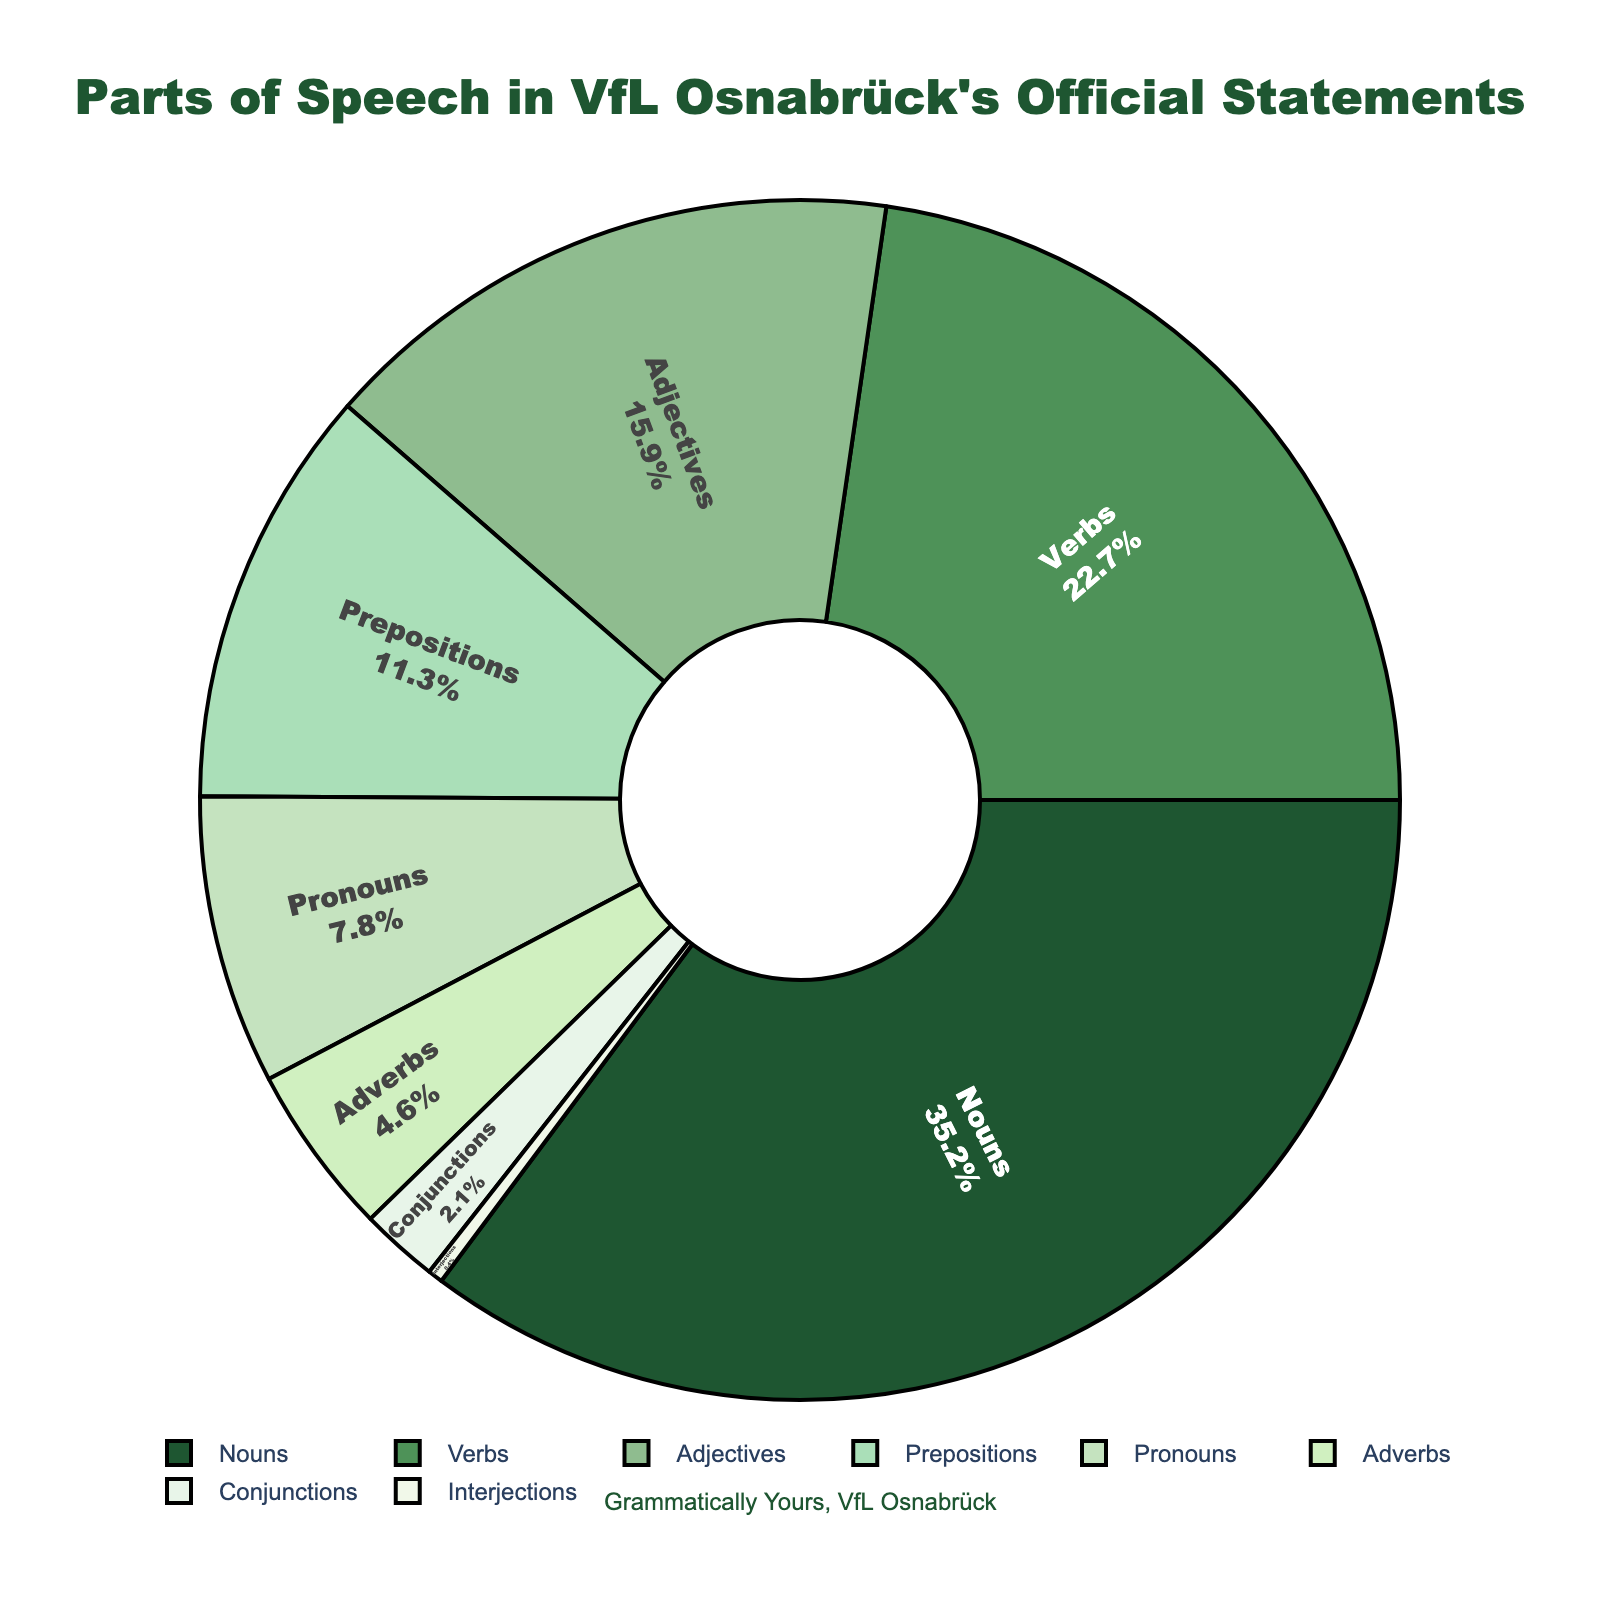What part of speech constitutes the largest percentage in VfL Osnabrück's official statements? Refer to the pie chart, observe which segment is the largest. The largest segment, labeled "Nouns," constitutes 35.2%.
Answer: Nouns What is the combined percentage of Nouns and Verbs in the official statements? Add the percentages of Nouns (35.2%) and Verbs (22.7%). \( 35.2\% + 22.7\% = 57.9\% \).
Answer: 57.9% Which part of speech has a smaller percentage, Pronouns or Adverbs? Compare the percentage values of Pronouns (7.8%) and Adverbs (4.6%). Adverbs have a smaller percentage.
Answer: Adverbs How much greater is the percentage of Adjectives compared to Prepositions in the official statements? Subtract the percentage of Prepositions (11.3%) from the percentage of Adjectives (15.9%). \( 15.9\% - 11.3\% = 4.6\% \).
Answer: 4.6% What is the total percentage of parts of speech that have a percentage less than 10%? Sum the percentages of Pronouns (7.8%), Adverbs (4.6%), Conjunctions (2.1%), and Interjections (0.4%). \( 7.8\% + 4.6\% + 2.1\% + 0.4\% = 14.9\% \).
Answer: 14.9% Which colored segment has the smallest value, and what is its corresponding part of speech? Look for the smallest segment by visual inspection. The smallest segment, colored light green, labels "Interjections" with 0.4%.
Answer: Interjections How many parts of speech have a percentage greater than 10%? Identify segments with percentages greater than 10%: Nouns (35.2%), Verbs (22.7%), Adjectives (15.9%), and Prepositions (11.3%). Count them: 4.
Answer: 4 Which part of speech has a percentage closest to the average percentage of all parts of speech? Find the average percentage: \( \frac{35.2\% + 22.7\% + 15.9\% + 11.3\% + 7.8\% + 4.6\% + 2.1\% + 0.4\%}{8} = 12.5\% \). Compare each percentage to 12.5%. Prepositions at 11.3% is closest.
Answer: Prepositions 